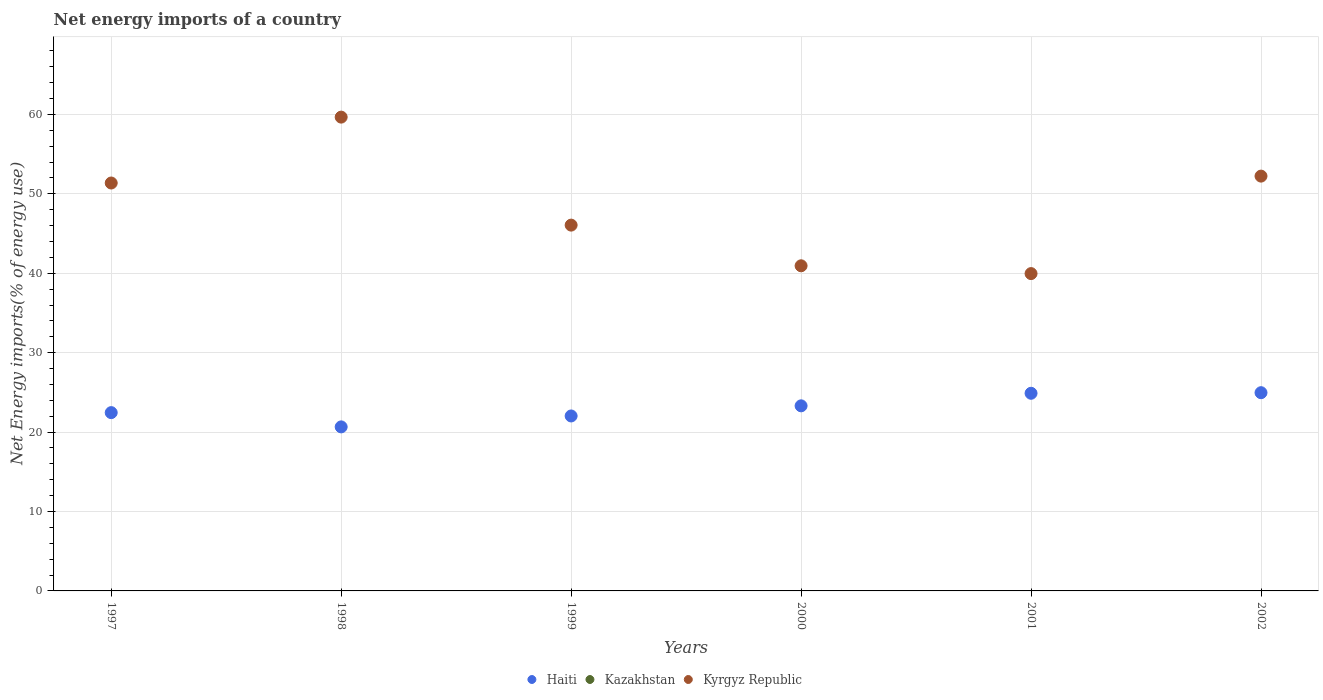What is the net energy imports in Kyrgyz Republic in 1998?
Provide a short and direct response. 59.67. Across all years, what is the maximum net energy imports in Kyrgyz Republic?
Your response must be concise. 59.67. Across all years, what is the minimum net energy imports in Haiti?
Provide a succinct answer. 20.66. In which year was the net energy imports in Kyrgyz Republic maximum?
Your answer should be compact. 1998. What is the total net energy imports in Haiti in the graph?
Your answer should be very brief. 138.3. What is the difference between the net energy imports in Kyrgyz Republic in 2001 and that in 2002?
Keep it short and to the point. -12.28. What is the difference between the net energy imports in Kyrgyz Republic in 1999 and the net energy imports in Kazakhstan in 2000?
Provide a succinct answer. 46.06. What is the average net energy imports in Haiti per year?
Make the answer very short. 23.05. In the year 1997, what is the difference between the net energy imports in Kyrgyz Republic and net energy imports in Haiti?
Offer a very short reply. 28.92. In how many years, is the net energy imports in Haiti greater than 40 %?
Offer a terse response. 0. What is the ratio of the net energy imports in Kyrgyz Republic in 1998 to that in 2000?
Your response must be concise. 1.46. Is the net energy imports in Haiti in 1998 less than that in 2002?
Ensure brevity in your answer.  Yes. What is the difference between the highest and the second highest net energy imports in Kyrgyz Republic?
Offer a terse response. 7.43. What is the difference between the highest and the lowest net energy imports in Kyrgyz Republic?
Provide a short and direct response. 19.7. In how many years, is the net energy imports in Haiti greater than the average net energy imports in Haiti taken over all years?
Your answer should be compact. 3. Does the net energy imports in Kazakhstan monotonically increase over the years?
Your answer should be compact. No. Is the net energy imports in Kyrgyz Republic strictly less than the net energy imports in Haiti over the years?
Offer a terse response. No. How many years are there in the graph?
Keep it short and to the point. 6. What is the difference between two consecutive major ticks on the Y-axis?
Offer a very short reply. 10. Are the values on the major ticks of Y-axis written in scientific E-notation?
Provide a succinct answer. No. Does the graph contain any zero values?
Your answer should be very brief. Yes. Does the graph contain grids?
Your response must be concise. Yes. How many legend labels are there?
Offer a terse response. 3. How are the legend labels stacked?
Give a very brief answer. Horizontal. What is the title of the graph?
Keep it short and to the point. Net energy imports of a country. Does "Cote d'Ivoire" appear as one of the legend labels in the graph?
Keep it short and to the point. No. What is the label or title of the Y-axis?
Provide a short and direct response. Net Energy imports(% of energy use). What is the Net Energy imports(% of energy use) of Haiti in 1997?
Ensure brevity in your answer.  22.45. What is the Net Energy imports(% of energy use) in Kazakhstan in 1997?
Offer a very short reply. 0. What is the Net Energy imports(% of energy use) of Kyrgyz Republic in 1997?
Your response must be concise. 51.37. What is the Net Energy imports(% of energy use) in Haiti in 1998?
Your answer should be very brief. 20.66. What is the Net Energy imports(% of energy use) of Kyrgyz Republic in 1998?
Ensure brevity in your answer.  59.67. What is the Net Energy imports(% of energy use) in Haiti in 1999?
Make the answer very short. 22.03. What is the Net Energy imports(% of energy use) in Kyrgyz Republic in 1999?
Offer a terse response. 46.06. What is the Net Energy imports(% of energy use) of Haiti in 2000?
Make the answer very short. 23.31. What is the Net Energy imports(% of energy use) in Kyrgyz Republic in 2000?
Your response must be concise. 40.94. What is the Net Energy imports(% of energy use) of Haiti in 2001?
Keep it short and to the point. 24.89. What is the Net Energy imports(% of energy use) in Kazakhstan in 2001?
Your answer should be very brief. 0. What is the Net Energy imports(% of energy use) of Kyrgyz Republic in 2001?
Provide a succinct answer. 39.96. What is the Net Energy imports(% of energy use) in Haiti in 2002?
Give a very brief answer. 24.96. What is the Net Energy imports(% of energy use) in Kyrgyz Republic in 2002?
Provide a short and direct response. 52.24. Across all years, what is the maximum Net Energy imports(% of energy use) in Haiti?
Your answer should be very brief. 24.96. Across all years, what is the maximum Net Energy imports(% of energy use) in Kyrgyz Republic?
Ensure brevity in your answer.  59.67. Across all years, what is the minimum Net Energy imports(% of energy use) in Haiti?
Make the answer very short. 20.66. Across all years, what is the minimum Net Energy imports(% of energy use) in Kyrgyz Republic?
Offer a very short reply. 39.96. What is the total Net Energy imports(% of energy use) in Haiti in the graph?
Your answer should be compact. 138.3. What is the total Net Energy imports(% of energy use) of Kazakhstan in the graph?
Give a very brief answer. 0. What is the total Net Energy imports(% of energy use) of Kyrgyz Republic in the graph?
Make the answer very short. 290.24. What is the difference between the Net Energy imports(% of energy use) of Haiti in 1997 and that in 1998?
Keep it short and to the point. 1.8. What is the difference between the Net Energy imports(% of energy use) of Kyrgyz Republic in 1997 and that in 1998?
Your answer should be compact. -8.3. What is the difference between the Net Energy imports(% of energy use) of Haiti in 1997 and that in 1999?
Keep it short and to the point. 0.42. What is the difference between the Net Energy imports(% of energy use) in Kyrgyz Republic in 1997 and that in 1999?
Offer a terse response. 5.3. What is the difference between the Net Energy imports(% of energy use) of Haiti in 1997 and that in 2000?
Provide a succinct answer. -0.85. What is the difference between the Net Energy imports(% of energy use) in Kyrgyz Republic in 1997 and that in 2000?
Give a very brief answer. 10.43. What is the difference between the Net Energy imports(% of energy use) of Haiti in 1997 and that in 2001?
Ensure brevity in your answer.  -2.44. What is the difference between the Net Energy imports(% of energy use) in Kyrgyz Republic in 1997 and that in 2001?
Keep it short and to the point. 11.41. What is the difference between the Net Energy imports(% of energy use) in Haiti in 1997 and that in 2002?
Keep it short and to the point. -2.51. What is the difference between the Net Energy imports(% of energy use) in Kyrgyz Republic in 1997 and that in 2002?
Ensure brevity in your answer.  -0.87. What is the difference between the Net Energy imports(% of energy use) in Haiti in 1998 and that in 1999?
Provide a short and direct response. -1.38. What is the difference between the Net Energy imports(% of energy use) in Kyrgyz Republic in 1998 and that in 1999?
Your answer should be very brief. 13.6. What is the difference between the Net Energy imports(% of energy use) in Haiti in 1998 and that in 2000?
Your response must be concise. -2.65. What is the difference between the Net Energy imports(% of energy use) of Kyrgyz Republic in 1998 and that in 2000?
Ensure brevity in your answer.  18.72. What is the difference between the Net Energy imports(% of energy use) in Haiti in 1998 and that in 2001?
Your answer should be compact. -4.23. What is the difference between the Net Energy imports(% of energy use) in Kyrgyz Republic in 1998 and that in 2001?
Offer a terse response. 19.7. What is the difference between the Net Energy imports(% of energy use) of Haiti in 1998 and that in 2002?
Make the answer very short. -4.31. What is the difference between the Net Energy imports(% of energy use) of Kyrgyz Republic in 1998 and that in 2002?
Ensure brevity in your answer.  7.43. What is the difference between the Net Energy imports(% of energy use) in Haiti in 1999 and that in 2000?
Make the answer very short. -1.28. What is the difference between the Net Energy imports(% of energy use) in Kyrgyz Republic in 1999 and that in 2000?
Make the answer very short. 5.12. What is the difference between the Net Energy imports(% of energy use) in Haiti in 1999 and that in 2001?
Keep it short and to the point. -2.86. What is the difference between the Net Energy imports(% of energy use) in Kyrgyz Republic in 1999 and that in 2001?
Keep it short and to the point. 6.1. What is the difference between the Net Energy imports(% of energy use) in Haiti in 1999 and that in 2002?
Provide a succinct answer. -2.93. What is the difference between the Net Energy imports(% of energy use) in Kyrgyz Republic in 1999 and that in 2002?
Give a very brief answer. -6.17. What is the difference between the Net Energy imports(% of energy use) in Haiti in 2000 and that in 2001?
Provide a succinct answer. -1.58. What is the difference between the Net Energy imports(% of energy use) of Kyrgyz Republic in 2000 and that in 2001?
Give a very brief answer. 0.98. What is the difference between the Net Energy imports(% of energy use) of Haiti in 2000 and that in 2002?
Offer a very short reply. -1.66. What is the difference between the Net Energy imports(% of energy use) of Kyrgyz Republic in 2000 and that in 2002?
Offer a terse response. -11.29. What is the difference between the Net Energy imports(% of energy use) in Haiti in 2001 and that in 2002?
Ensure brevity in your answer.  -0.07. What is the difference between the Net Energy imports(% of energy use) of Kyrgyz Republic in 2001 and that in 2002?
Offer a very short reply. -12.28. What is the difference between the Net Energy imports(% of energy use) in Haiti in 1997 and the Net Energy imports(% of energy use) in Kyrgyz Republic in 1998?
Provide a succinct answer. -37.21. What is the difference between the Net Energy imports(% of energy use) of Haiti in 1997 and the Net Energy imports(% of energy use) of Kyrgyz Republic in 1999?
Provide a short and direct response. -23.61. What is the difference between the Net Energy imports(% of energy use) of Haiti in 1997 and the Net Energy imports(% of energy use) of Kyrgyz Republic in 2000?
Provide a short and direct response. -18.49. What is the difference between the Net Energy imports(% of energy use) in Haiti in 1997 and the Net Energy imports(% of energy use) in Kyrgyz Republic in 2001?
Ensure brevity in your answer.  -17.51. What is the difference between the Net Energy imports(% of energy use) of Haiti in 1997 and the Net Energy imports(% of energy use) of Kyrgyz Republic in 2002?
Keep it short and to the point. -29.78. What is the difference between the Net Energy imports(% of energy use) of Haiti in 1998 and the Net Energy imports(% of energy use) of Kyrgyz Republic in 1999?
Your answer should be very brief. -25.41. What is the difference between the Net Energy imports(% of energy use) in Haiti in 1998 and the Net Energy imports(% of energy use) in Kyrgyz Republic in 2000?
Offer a very short reply. -20.29. What is the difference between the Net Energy imports(% of energy use) of Haiti in 1998 and the Net Energy imports(% of energy use) of Kyrgyz Republic in 2001?
Keep it short and to the point. -19.3. What is the difference between the Net Energy imports(% of energy use) of Haiti in 1998 and the Net Energy imports(% of energy use) of Kyrgyz Republic in 2002?
Make the answer very short. -31.58. What is the difference between the Net Energy imports(% of energy use) of Haiti in 1999 and the Net Energy imports(% of energy use) of Kyrgyz Republic in 2000?
Provide a short and direct response. -18.91. What is the difference between the Net Energy imports(% of energy use) of Haiti in 1999 and the Net Energy imports(% of energy use) of Kyrgyz Republic in 2001?
Make the answer very short. -17.93. What is the difference between the Net Energy imports(% of energy use) in Haiti in 1999 and the Net Energy imports(% of energy use) in Kyrgyz Republic in 2002?
Make the answer very short. -30.2. What is the difference between the Net Energy imports(% of energy use) in Haiti in 2000 and the Net Energy imports(% of energy use) in Kyrgyz Republic in 2001?
Ensure brevity in your answer.  -16.65. What is the difference between the Net Energy imports(% of energy use) in Haiti in 2000 and the Net Energy imports(% of energy use) in Kyrgyz Republic in 2002?
Your answer should be very brief. -28.93. What is the difference between the Net Energy imports(% of energy use) of Haiti in 2001 and the Net Energy imports(% of energy use) of Kyrgyz Republic in 2002?
Provide a short and direct response. -27.35. What is the average Net Energy imports(% of energy use) of Haiti per year?
Your response must be concise. 23.05. What is the average Net Energy imports(% of energy use) of Kyrgyz Republic per year?
Your response must be concise. 48.37. In the year 1997, what is the difference between the Net Energy imports(% of energy use) in Haiti and Net Energy imports(% of energy use) in Kyrgyz Republic?
Ensure brevity in your answer.  -28.92. In the year 1998, what is the difference between the Net Energy imports(% of energy use) of Haiti and Net Energy imports(% of energy use) of Kyrgyz Republic?
Keep it short and to the point. -39.01. In the year 1999, what is the difference between the Net Energy imports(% of energy use) of Haiti and Net Energy imports(% of energy use) of Kyrgyz Republic?
Give a very brief answer. -24.03. In the year 2000, what is the difference between the Net Energy imports(% of energy use) of Haiti and Net Energy imports(% of energy use) of Kyrgyz Republic?
Your response must be concise. -17.64. In the year 2001, what is the difference between the Net Energy imports(% of energy use) in Haiti and Net Energy imports(% of energy use) in Kyrgyz Republic?
Offer a very short reply. -15.07. In the year 2002, what is the difference between the Net Energy imports(% of energy use) in Haiti and Net Energy imports(% of energy use) in Kyrgyz Republic?
Ensure brevity in your answer.  -27.27. What is the ratio of the Net Energy imports(% of energy use) in Haiti in 1997 to that in 1998?
Provide a short and direct response. 1.09. What is the ratio of the Net Energy imports(% of energy use) of Kyrgyz Republic in 1997 to that in 1998?
Ensure brevity in your answer.  0.86. What is the ratio of the Net Energy imports(% of energy use) in Haiti in 1997 to that in 1999?
Offer a terse response. 1.02. What is the ratio of the Net Energy imports(% of energy use) of Kyrgyz Republic in 1997 to that in 1999?
Offer a very short reply. 1.12. What is the ratio of the Net Energy imports(% of energy use) in Haiti in 1997 to that in 2000?
Ensure brevity in your answer.  0.96. What is the ratio of the Net Energy imports(% of energy use) in Kyrgyz Republic in 1997 to that in 2000?
Your answer should be compact. 1.25. What is the ratio of the Net Energy imports(% of energy use) in Haiti in 1997 to that in 2001?
Make the answer very short. 0.9. What is the ratio of the Net Energy imports(% of energy use) in Kyrgyz Republic in 1997 to that in 2001?
Offer a terse response. 1.29. What is the ratio of the Net Energy imports(% of energy use) in Haiti in 1997 to that in 2002?
Ensure brevity in your answer.  0.9. What is the ratio of the Net Energy imports(% of energy use) in Kyrgyz Republic in 1997 to that in 2002?
Provide a succinct answer. 0.98. What is the ratio of the Net Energy imports(% of energy use) of Haiti in 1998 to that in 1999?
Keep it short and to the point. 0.94. What is the ratio of the Net Energy imports(% of energy use) of Kyrgyz Republic in 1998 to that in 1999?
Your answer should be very brief. 1.3. What is the ratio of the Net Energy imports(% of energy use) of Haiti in 1998 to that in 2000?
Your answer should be very brief. 0.89. What is the ratio of the Net Energy imports(% of energy use) of Kyrgyz Republic in 1998 to that in 2000?
Your answer should be very brief. 1.46. What is the ratio of the Net Energy imports(% of energy use) of Haiti in 1998 to that in 2001?
Keep it short and to the point. 0.83. What is the ratio of the Net Energy imports(% of energy use) of Kyrgyz Republic in 1998 to that in 2001?
Your answer should be very brief. 1.49. What is the ratio of the Net Energy imports(% of energy use) in Haiti in 1998 to that in 2002?
Offer a very short reply. 0.83. What is the ratio of the Net Energy imports(% of energy use) of Kyrgyz Republic in 1998 to that in 2002?
Give a very brief answer. 1.14. What is the ratio of the Net Energy imports(% of energy use) of Haiti in 1999 to that in 2000?
Ensure brevity in your answer.  0.95. What is the ratio of the Net Energy imports(% of energy use) in Kyrgyz Republic in 1999 to that in 2000?
Your response must be concise. 1.13. What is the ratio of the Net Energy imports(% of energy use) of Haiti in 1999 to that in 2001?
Ensure brevity in your answer.  0.89. What is the ratio of the Net Energy imports(% of energy use) of Kyrgyz Republic in 1999 to that in 2001?
Make the answer very short. 1.15. What is the ratio of the Net Energy imports(% of energy use) of Haiti in 1999 to that in 2002?
Your answer should be compact. 0.88. What is the ratio of the Net Energy imports(% of energy use) in Kyrgyz Republic in 1999 to that in 2002?
Offer a very short reply. 0.88. What is the ratio of the Net Energy imports(% of energy use) in Haiti in 2000 to that in 2001?
Make the answer very short. 0.94. What is the ratio of the Net Energy imports(% of energy use) in Kyrgyz Republic in 2000 to that in 2001?
Provide a short and direct response. 1.02. What is the ratio of the Net Energy imports(% of energy use) of Haiti in 2000 to that in 2002?
Your answer should be compact. 0.93. What is the ratio of the Net Energy imports(% of energy use) in Kyrgyz Republic in 2000 to that in 2002?
Give a very brief answer. 0.78. What is the ratio of the Net Energy imports(% of energy use) of Haiti in 2001 to that in 2002?
Offer a very short reply. 1. What is the ratio of the Net Energy imports(% of energy use) of Kyrgyz Republic in 2001 to that in 2002?
Give a very brief answer. 0.77. What is the difference between the highest and the second highest Net Energy imports(% of energy use) in Haiti?
Give a very brief answer. 0.07. What is the difference between the highest and the second highest Net Energy imports(% of energy use) of Kyrgyz Republic?
Offer a terse response. 7.43. What is the difference between the highest and the lowest Net Energy imports(% of energy use) in Haiti?
Give a very brief answer. 4.31. What is the difference between the highest and the lowest Net Energy imports(% of energy use) in Kyrgyz Republic?
Your response must be concise. 19.7. 